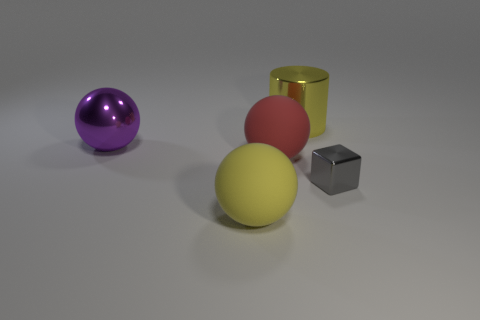Subtract all purple blocks. Subtract all gray spheres. How many blocks are left? 1 Add 3 tiny red matte cubes. How many objects exist? 8 Subtract all balls. How many objects are left? 2 Add 2 big purple metal objects. How many big purple metal objects are left? 3 Add 4 large yellow objects. How many large yellow objects exist? 6 Subtract 1 gray cubes. How many objects are left? 4 Subtract all tiny red matte objects. Subtract all big purple things. How many objects are left? 4 